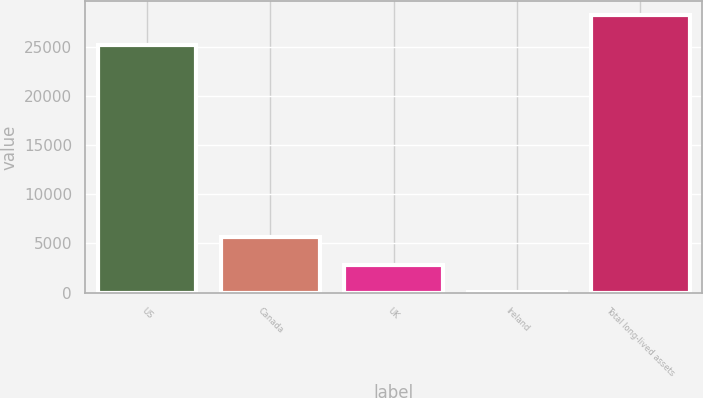Convert chart. <chart><loc_0><loc_0><loc_500><loc_500><bar_chart><fcel>US<fcel>Canada<fcel>UK<fcel>Ireland<fcel>Total long-lived assets<nl><fcel>25210<fcel>5664.4<fcel>2842.2<fcel>20<fcel>28242<nl></chart> 